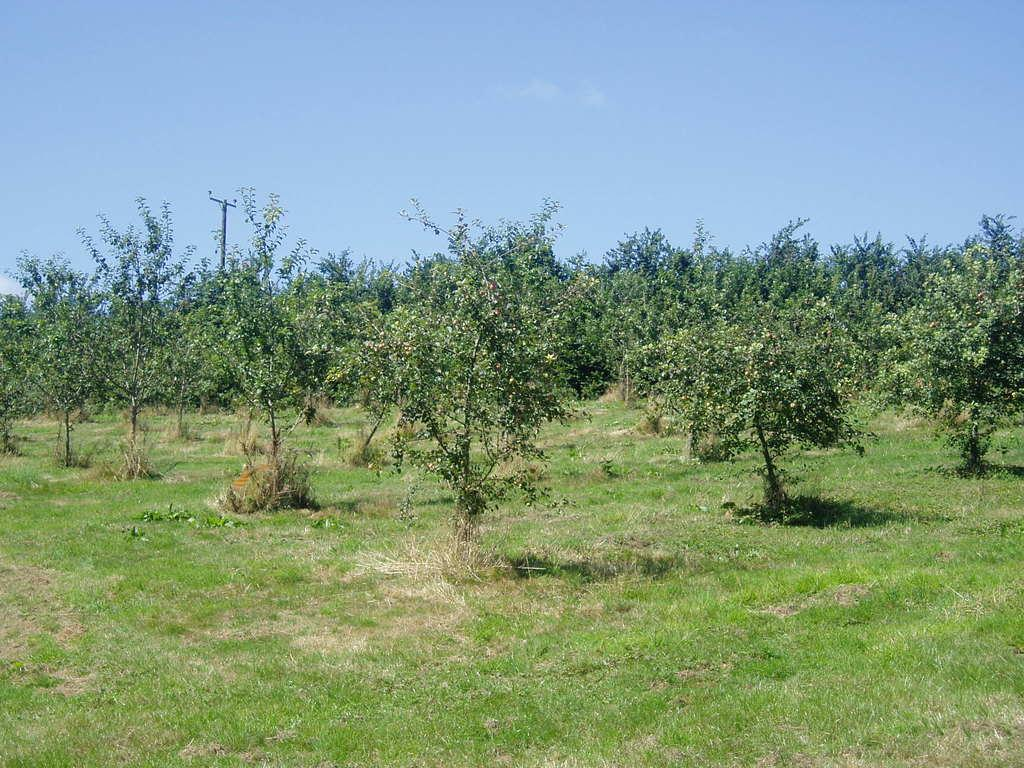What type of vegetation can be seen in the image? There are trees in the image. What is covering the ground in the image? There is grass on the ground in the image. What structure is present in the image? There is a pole in the image. What color is the sky in the image? The sky is blue in the image. What time of day is the maid sweeping the grass in the image? There is no maid present in the image, and the grass is not being swept. 